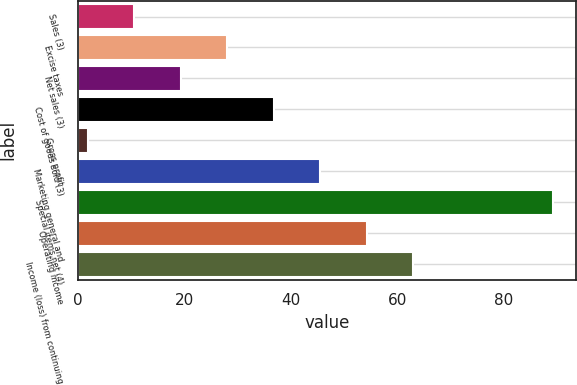Convert chart. <chart><loc_0><loc_0><loc_500><loc_500><bar_chart><fcel>Sales (3)<fcel>Excise taxes<fcel>Net sales (3)<fcel>Cost of goods sold (3)<fcel>Gross profit<fcel>Marketing general and<fcel>Special items net (4)<fcel>Operating income<fcel>Income (loss) from continuing<nl><fcel>10.63<fcel>28.09<fcel>19.36<fcel>36.82<fcel>1.9<fcel>45.55<fcel>89.2<fcel>54.28<fcel>63.01<nl></chart> 